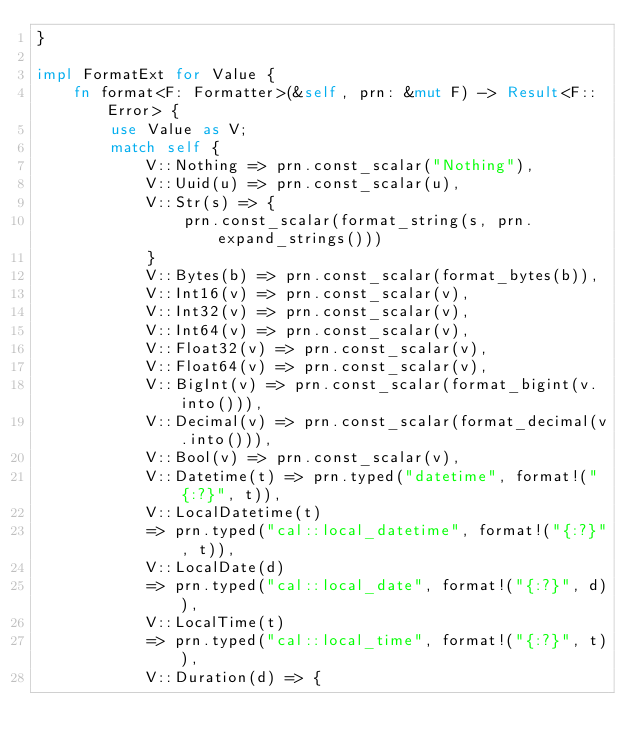Convert code to text. <code><loc_0><loc_0><loc_500><loc_500><_Rust_>}

impl FormatExt for Value {
    fn format<F: Formatter>(&self, prn: &mut F) -> Result<F::Error> {
        use Value as V;
        match self {
            V::Nothing => prn.const_scalar("Nothing"),
            V::Uuid(u) => prn.const_scalar(u),
            V::Str(s) => {
                prn.const_scalar(format_string(s, prn.expand_strings()))
            }
            V::Bytes(b) => prn.const_scalar(format_bytes(b)),
            V::Int16(v) => prn.const_scalar(v),
            V::Int32(v) => prn.const_scalar(v),
            V::Int64(v) => prn.const_scalar(v),
            V::Float32(v) => prn.const_scalar(v),
            V::Float64(v) => prn.const_scalar(v),
            V::BigInt(v) => prn.const_scalar(format_bigint(v.into())),
            V::Decimal(v) => prn.const_scalar(format_decimal(v.into())),
            V::Bool(v) => prn.const_scalar(v),
            V::Datetime(t) => prn.typed("datetime", format!("{:?}", t)),
            V::LocalDatetime(t)
            => prn.typed("cal::local_datetime", format!("{:?}", t)),
            V::LocalDate(d)
            => prn.typed("cal::local_date", format!("{:?}", d)),
            V::LocalTime(t)
            => prn.typed("cal::local_time", format!("{:?}", t)),
            V::Duration(d) => {</code> 